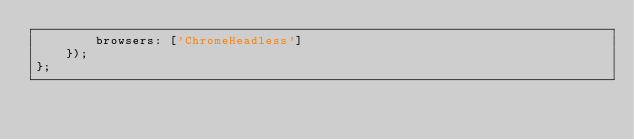<code> <loc_0><loc_0><loc_500><loc_500><_JavaScript_>        browsers: ['ChromeHeadless']
    });
};
</code> 